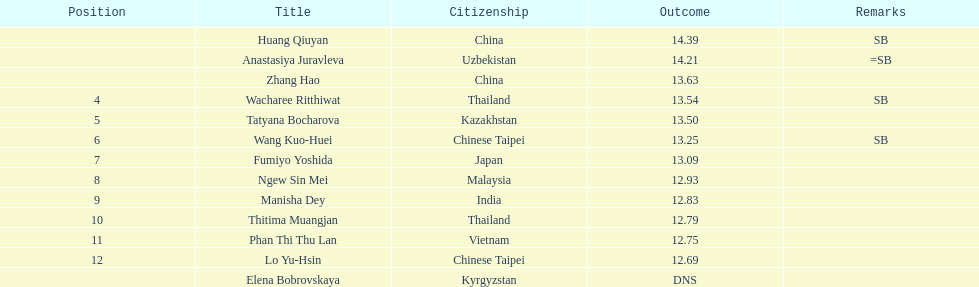Which country came in first? China. 